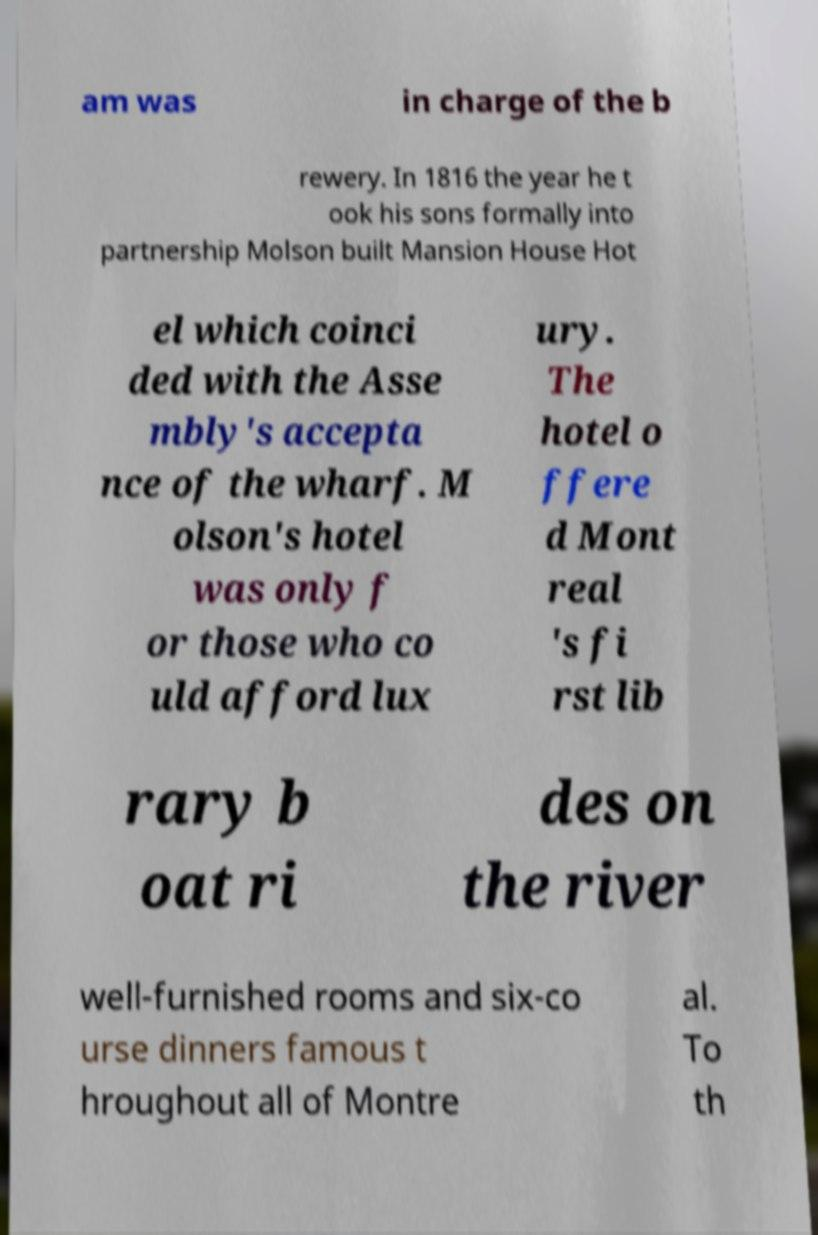Please identify and transcribe the text found in this image. am was in charge of the b rewery. In 1816 the year he t ook his sons formally into partnership Molson built Mansion House Hot el which coinci ded with the Asse mbly's accepta nce of the wharf. M olson's hotel was only f or those who co uld afford lux ury. The hotel o ffere d Mont real 's fi rst lib rary b oat ri des on the river well-furnished rooms and six-co urse dinners famous t hroughout all of Montre al. To th 